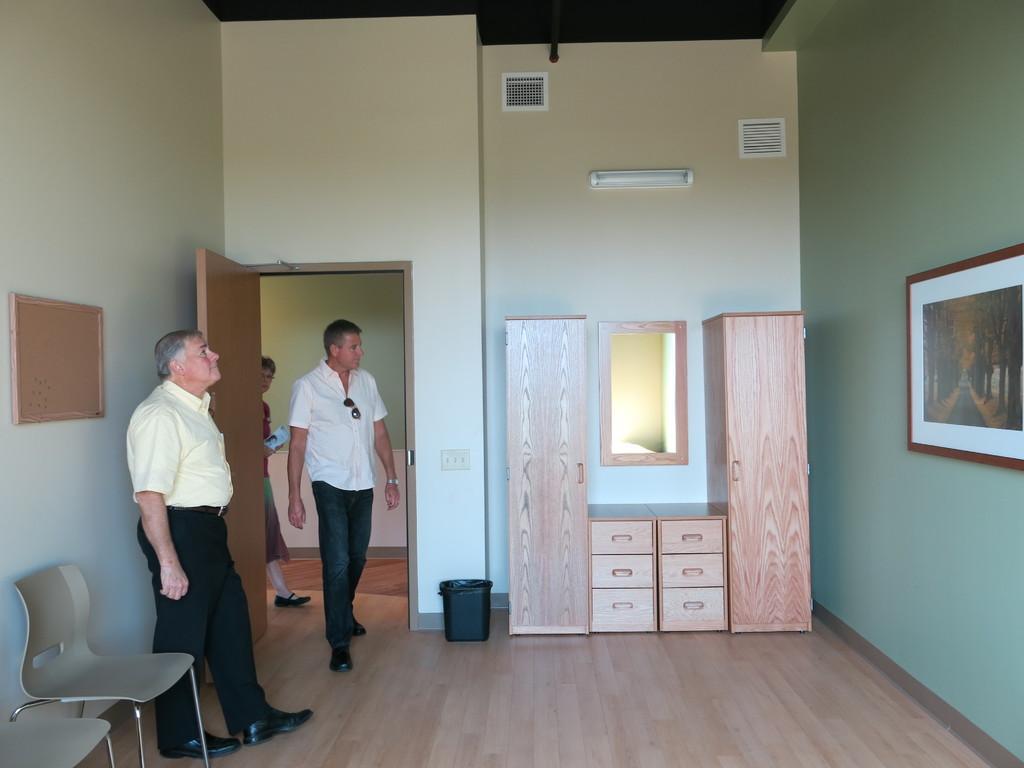Can you describe this image briefly? As we can see in a picture that, there are three person two men and one women. These are the chair. There is a dustbin in a room. These are the cupboard. 